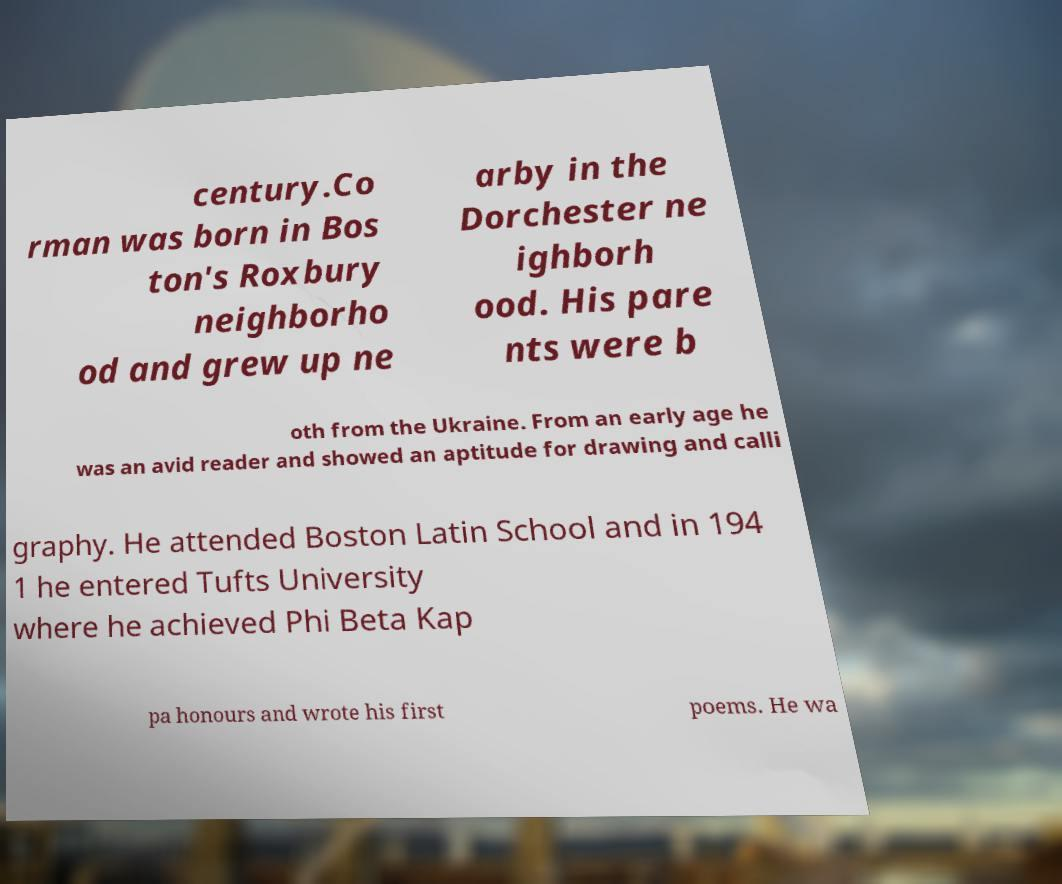I need the written content from this picture converted into text. Can you do that? century.Co rman was born in Bos ton's Roxbury neighborho od and grew up ne arby in the Dorchester ne ighborh ood. His pare nts were b oth from the Ukraine. From an early age he was an avid reader and showed an aptitude for drawing and calli graphy. He attended Boston Latin School and in 194 1 he entered Tufts University where he achieved Phi Beta Kap pa honours and wrote his first poems. He wa 